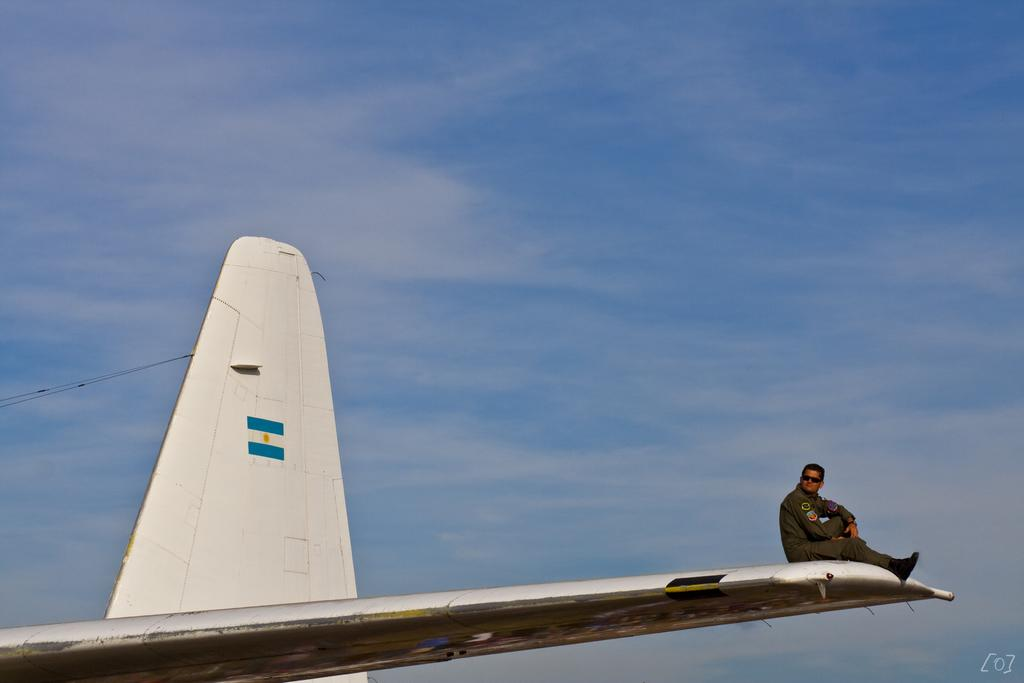What is the man in the image sitting on? There is a man sitting on an airplane in the image. What can be seen in the background of the image? The sky is visible in the background of the image. How many tents are set up near the airplane in the image? There are no tents present in the image. What type of chairs are visible in the image? There are no chairs visible in the image. What is the color of the cream being served on the airplane? There is no cream being served on the airplane in the image. 